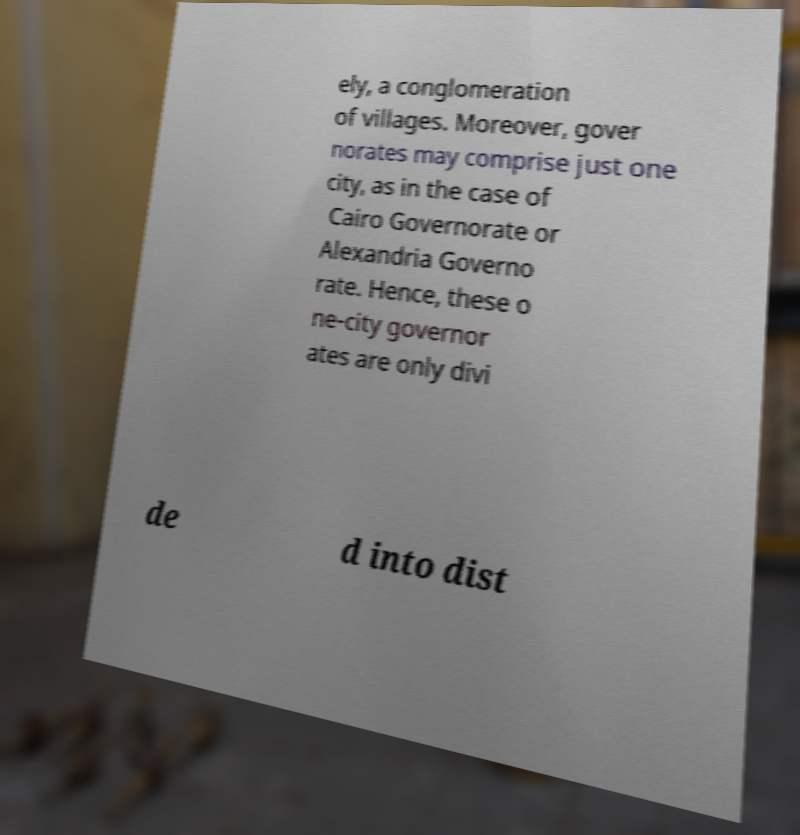There's text embedded in this image that I need extracted. Can you transcribe it verbatim? ely, a conglomeration of villages. Moreover, gover norates may comprise just one city, as in the case of Cairo Governorate or Alexandria Governo rate. Hence, these o ne-city governor ates are only divi de d into dist 